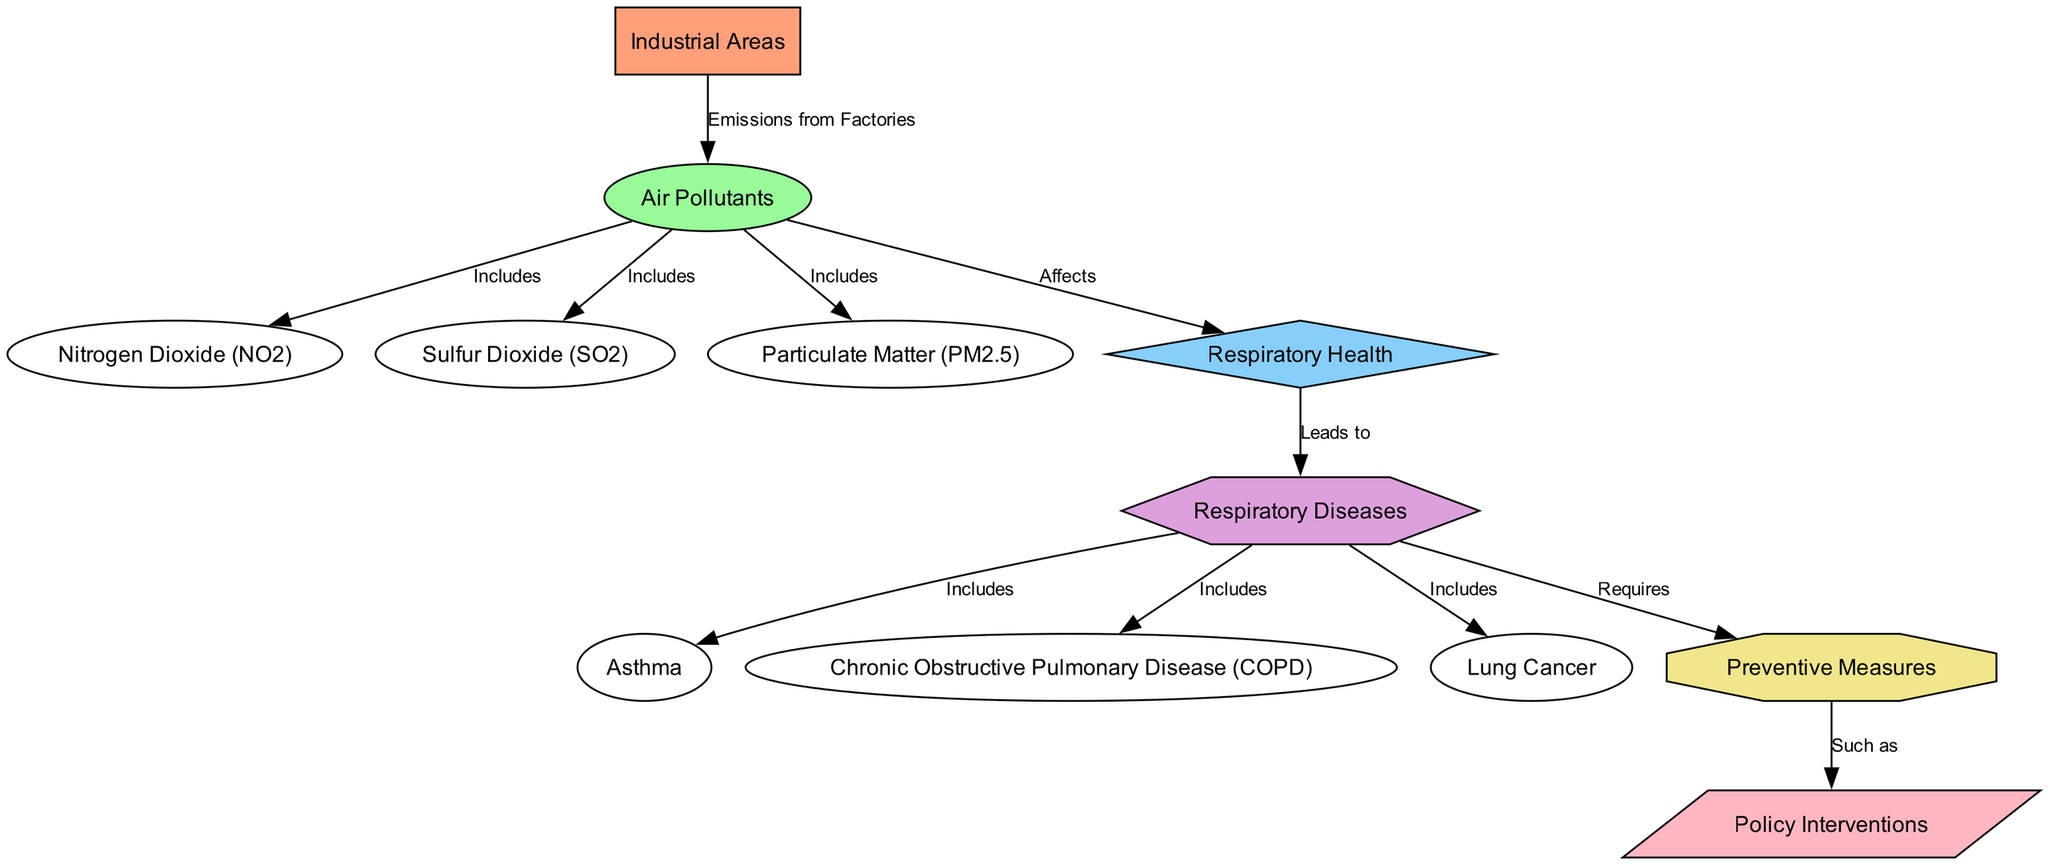What are the main air pollutants included in the diagram? The diagram lists three main air pollutants: Nitrogen Dioxide (NO2), Sulfur Dioxide (SO2), and Particulate Matter (PM2.5). This information is shown under the 'airPollutants' node, which indicates that these pollutants are part of the emissions affecting respiratory health.
Answer: Nitrogen Dioxide (NO2), Sulfur Dioxide (SO2), Particulate Matter (PM2.5) How many respiratory diseases are listed in the diagram? The diagram shows that there are three respiratory diseases linked to 'respiratoryDiseases': Asthma, Chronic Obstructive Pulmonary Disease (COPD), and Lung Cancer. This is found under the 'respiratoryDiseases' node, which directly includes these as sub-nodes.
Answer: 3 What affects respiratory health according to the diagram? The diagram indicates that 'airPollutants' affect 'respiratoryHealth'. The edge between the 'airPollutants' and 'respiratoryHealth' nodes specifies this relationship, confirming that air pollutants directly impact respiratory health.
Answer: airPollutants What requires preventive measures? Under the 'respiratoryDiseases' node, it states that 'preventiveMeasures' are needed. This indicates that when respiratory diseases occur, preventive actions must be taken, showing the connection between the two nodes.
Answer: respiratoryDiseases What type of interventions are suggested in the diagram? The diagram mentions 'policyInterventions' as a type of intervention related to 'preventiveMeasures', suggesting that certain policies may be implemented as part of the preventive actions needed for respiratory issues.
Answer: policyInterventions What is the flow from industrial areas to respiratory diseases? The flow starts from 'industrialAreas', which emits 'airPollutants'. These pollutants then affect 'respiratoryHealth', leading to 'respiratoryDiseases'. This step-by-step flow illustrates how industrial emissions can impact health through multiple stages.
Answer: industrialAreas to respiratoryDiseases What is the significance of Particulate Matter (PM2.5) in the context of the diagram? Particulate Matter (PM2.5) is one of the main air pollutants included under the 'airPollutants' node, signifying that it is a significant contributor to the adverse effects on 'respiratoryHealth'. This relationship emphasizes its importance in the context of respiratory issues.
Answer: significant contributor 